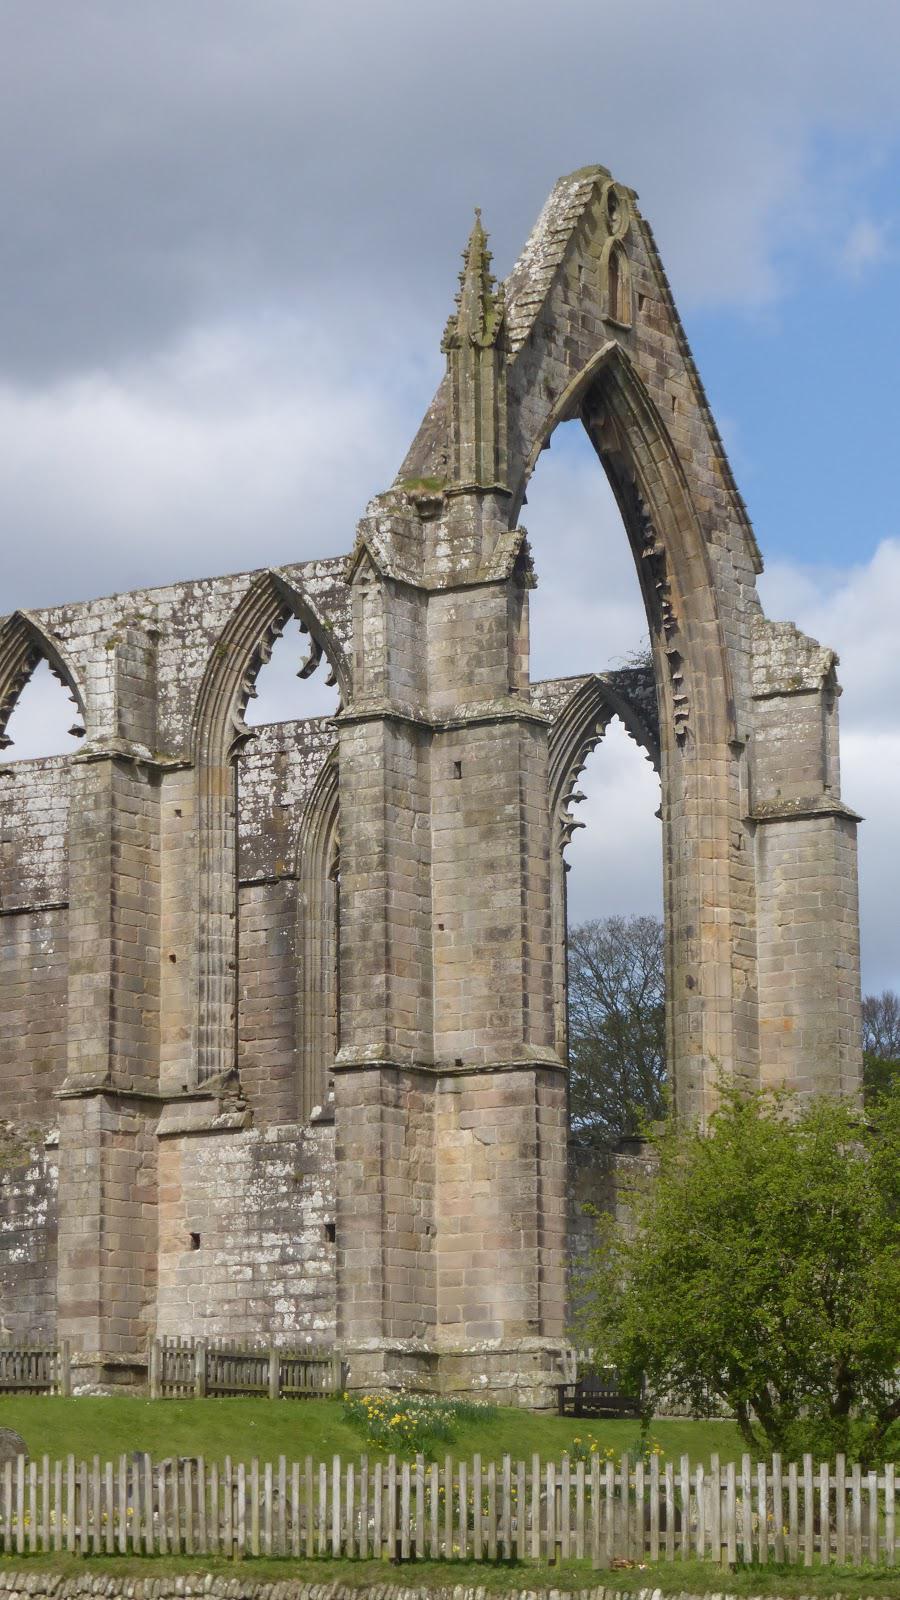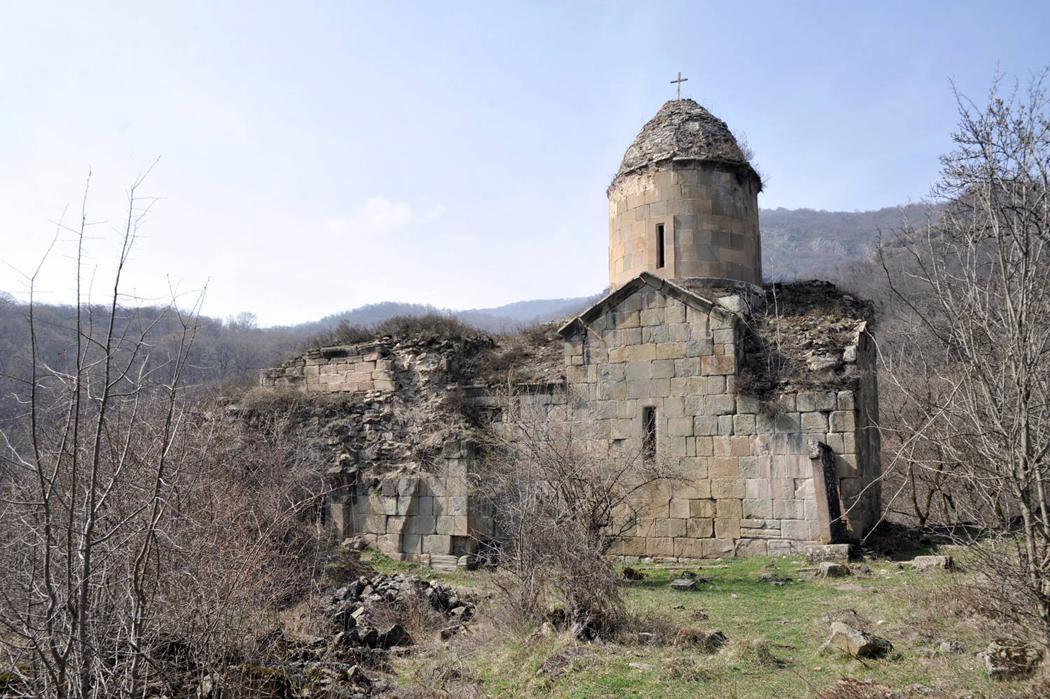The first image is the image on the left, the second image is the image on the right. Considering the images on both sides, is "In one image, a large building is red with white trim and a black decorative rooftop." valid? Answer yes or no. No. The first image is the image on the left, the second image is the image on the right. Considering the images on both sides, is "One image shows a building topped with multiple dark gray onion-shapes with crosses on top." valid? Answer yes or no. No. 